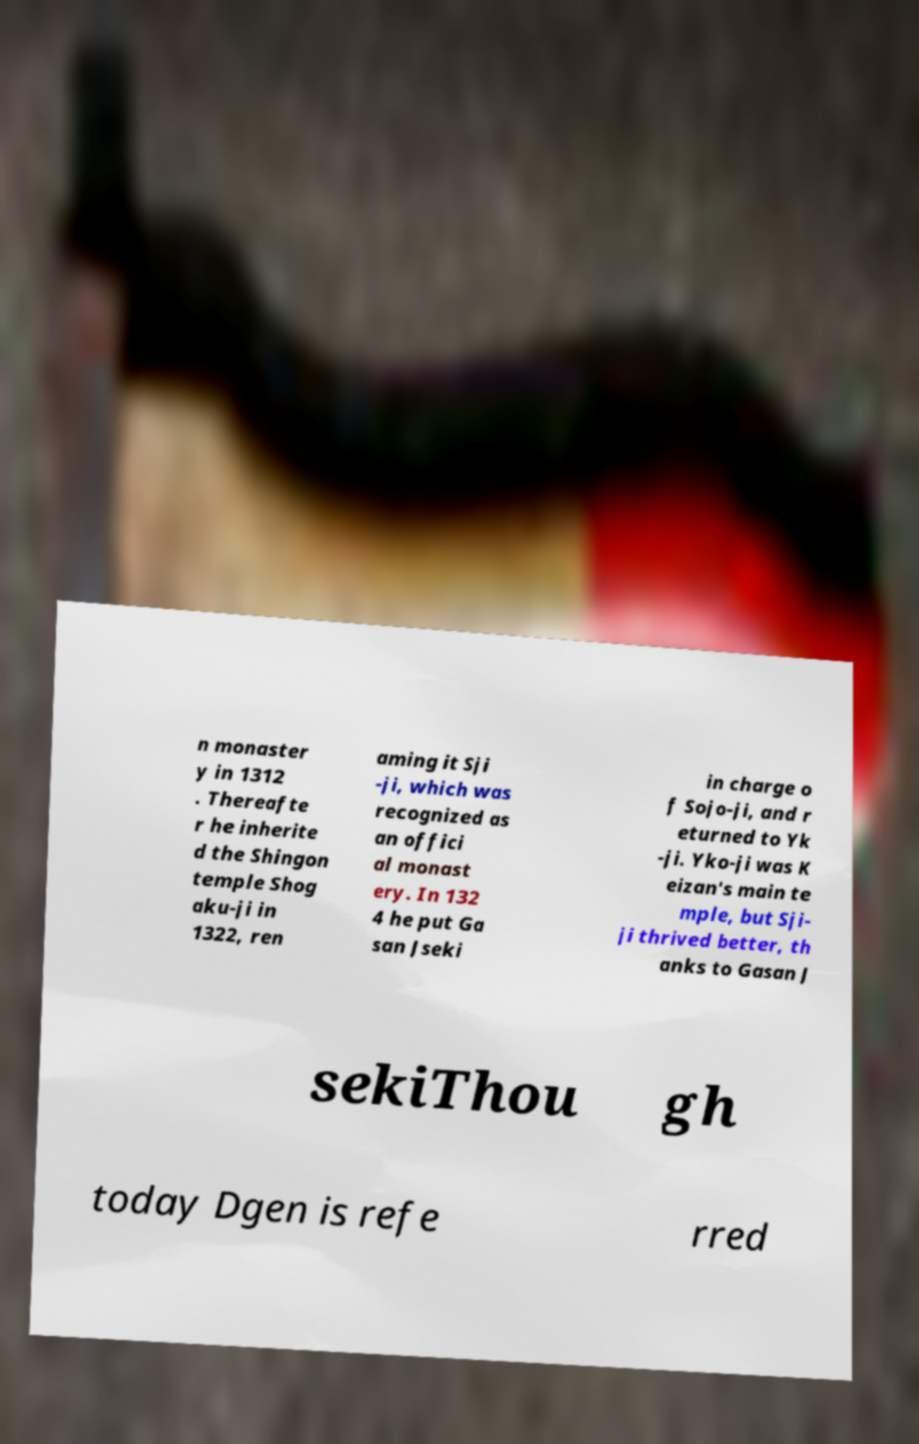Could you extract and type out the text from this image? n monaster y in 1312 . Thereafte r he inherite d the Shingon temple Shog aku-ji in 1322, ren aming it Sji -ji, which was recognized as an offici al monast ery. In 132 4 he put Ga san Jseki in charge o f Sojo-ji, and r eturned to Yk -ji. Yko-ji was K eizan's main te mple, but Sji- ji thrived better, th anks to Gasan J sekiThou gh today Dgen is refe rred 